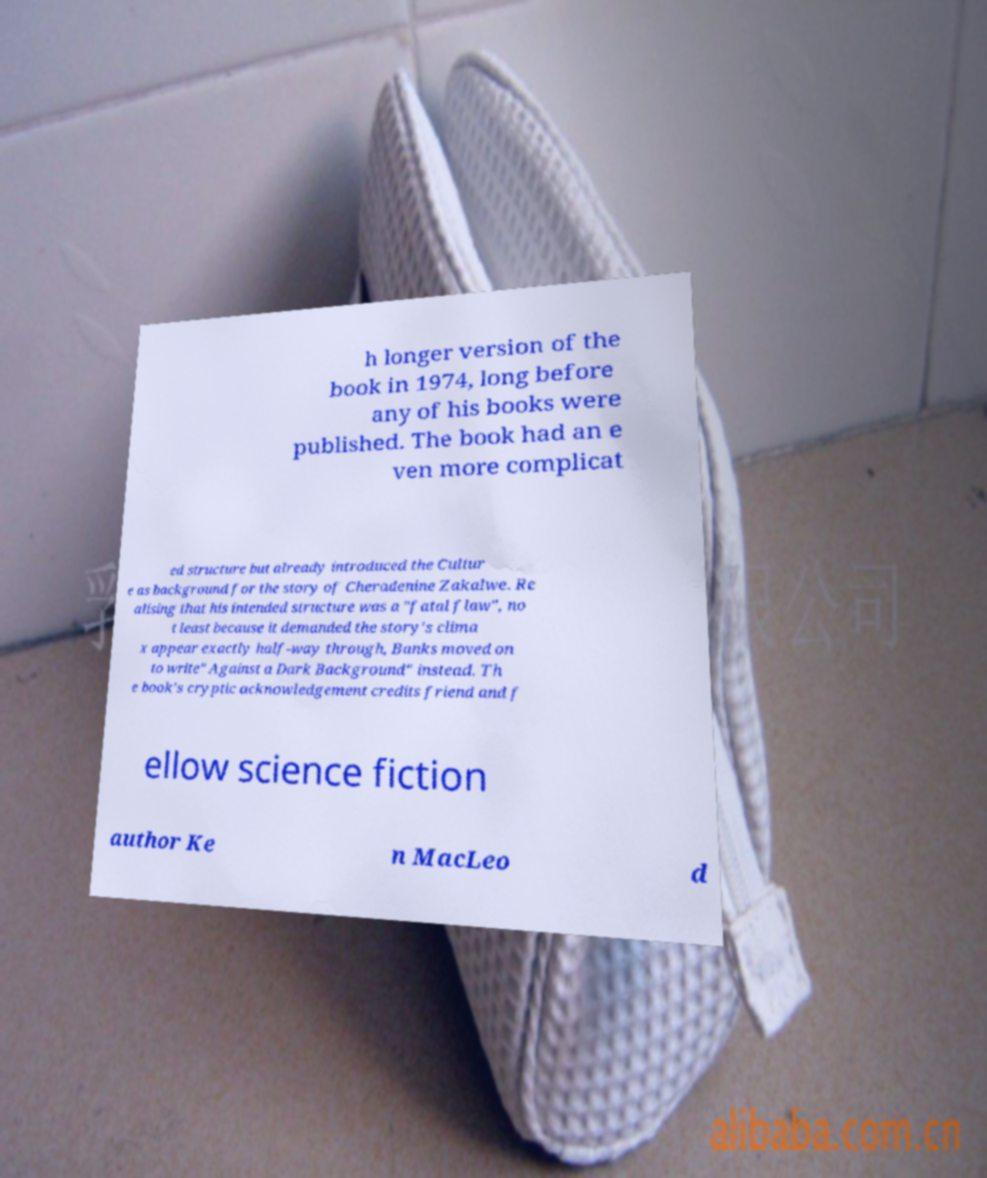Could you extract and type out the text from this image? h longer version of the book in 1974, long before any of his books were published. The book had an e ven more complicat ed structure but already introduced the Cultur e as background for the story of Cheradenine Zakalwe. Re alising that his intended structure was a "fatal flaw", no t least because it demanded the story's clima x appear exactly half-way through, Banks moved on to write" Against a Dark Background" instead. Th e book's cryptic acknowledgement credits friend and f ellow science fiction author Ke n MacLeo d 